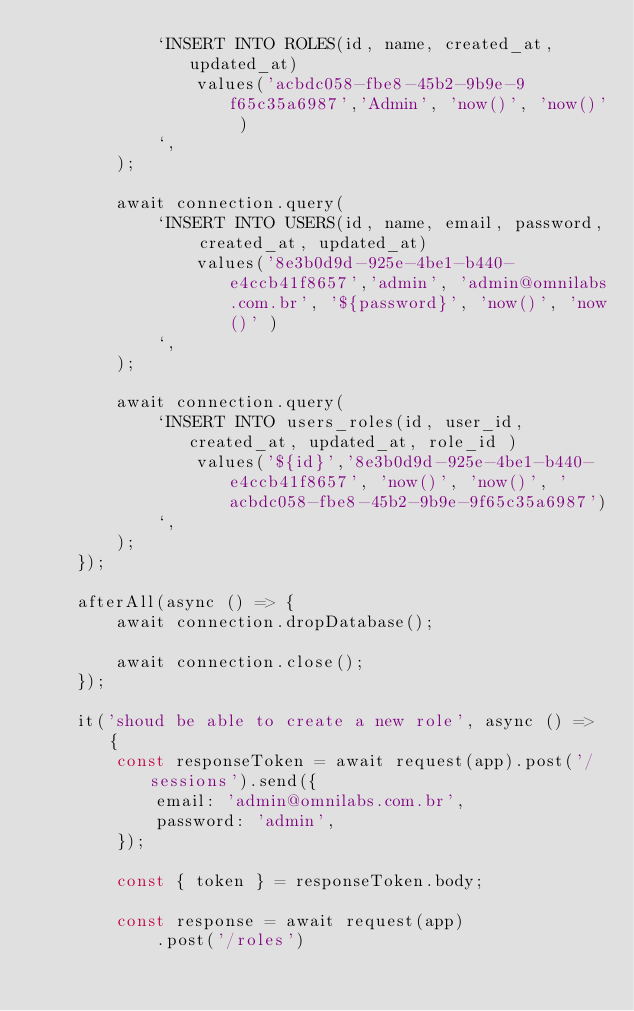Convert code to text. <code><loc_0><loc_0><loc_500><loc_500><_TypeScript_>            `INSERT INTO ROLES(id, name, created_at, updated_at)
                values('acbdc058-fbe8-45b2-9b9e-9f65c35a6987','Admin', 'now()', 'now()' )
            `,
        );

        await connection.query(
            `INSERT INTO USERS(id, name, email, password, created_at, updated_at)
                values('8e3b0d9d-925e-4be1-b440-e4ccb41f8657','admin', 'admin@omnilabs.com.br', '${password}', 'now()', 'now()' )
            `,
        );

        await connection.query(
            `INSERT INTO users_roles(id, user_id, created_at, updated_at, role_id )
                values('${id}','8e3b0d9d-925e-4be1-b440-e4ccb41f8657', 'now()', 'now()', 'acbdc058-fbe8-45b2-9b9e-9f65c35a6987')
            `,
        );
    });

    afterAll(async () => {
        await connection.dropDatabase();

        await connection.close();
    });

    it('shoud be able to create a new role', async () => {
        const responseToken = await request(app).post('/sessions').send({
            email: 'admin@omnilabs.com.br',
            password: 'admin',
        });

        const { token } = responseToken.body;

        const response = await request(app)
            .post('/roles')</code> 